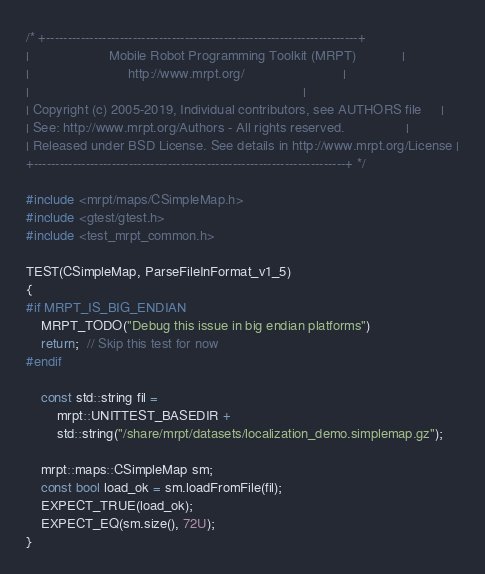Convert code to text. <code><loc_0><loc_0><loc_500><loc_500><_C++_>/* +------------------------------------------------------------------------+
|                     Mobile Robot Programming Toolkit (MRPT)            |
|                          http://www.mrpt.org/                          |
|                                                                        |
| Copyright (c) 2005-2019, Individual contributors, see AUTHORS file     |
| See: http://www.mrpt.org/Authors - All rights reserved.                |
| Released under BSD License. See details in http://www.mrpt.org/License |
+------------------------------------------------------------------------+ */

#include <mrpt/maps/CSimpleMap.h>
#include <gtest/gtest.h>
#include <test_mrpt_common.h>

TEST(CSimpleMap, ParseFileInFormat_v1_5)
{
#if MRPT_IS_BIG_ENDIAN
	MRPT_TODO("Debug this issue in big endian platforms")
	return;  // Skip this test for now
#endif

	const std::string fil =
		mrpt::UNITTEST_BASEDIR +
		std::string("/share/mrpt/datasets/localization_demo.simplemap.gz");

	mrpt::maps::CSimpleMap sm;
	const bool load_ok = sm.loadFromFile(fil);
	EXPECT_TRUE(load_ok);
	EXPECT_EQ(sm.size(), 72U);
}
</code> 